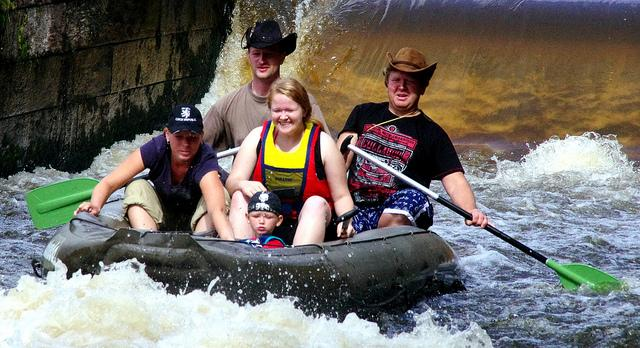What is this boat called? Please explain your reasoning. raft. The boat is a raft. 